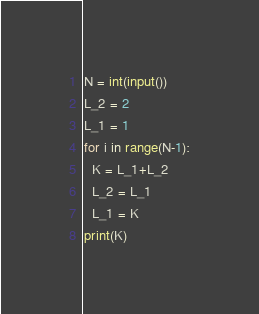Convert code to text. <code><loc_0><loc_0><loc_500><loc_500><_Python_>N = int(input())
L_2 = 2
L_1 = 1
for i in range(N-1):
  K = L_1+L_2
  L_2 = L_1
  L_1 = K
print(K)
</code> 